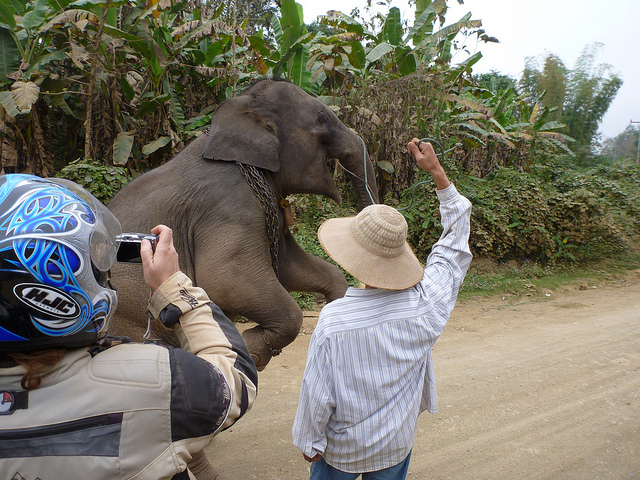<image>Which foot does the man have forward? I am not sure which foot the man has forward. It could be either left or right. Which foot does the man have forward? I am not sure which foot does the man have forward. It can be either left or right. 